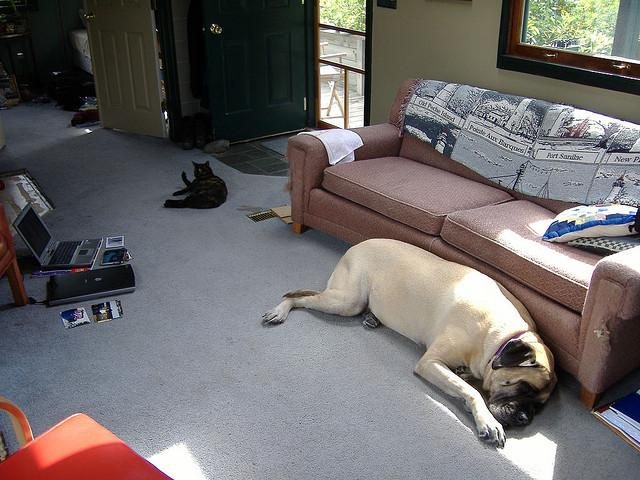Where is the person most likely working in the living room while the pets lounge?

Choices:
A) floor
B) sofa
C) desk
D) table floor 